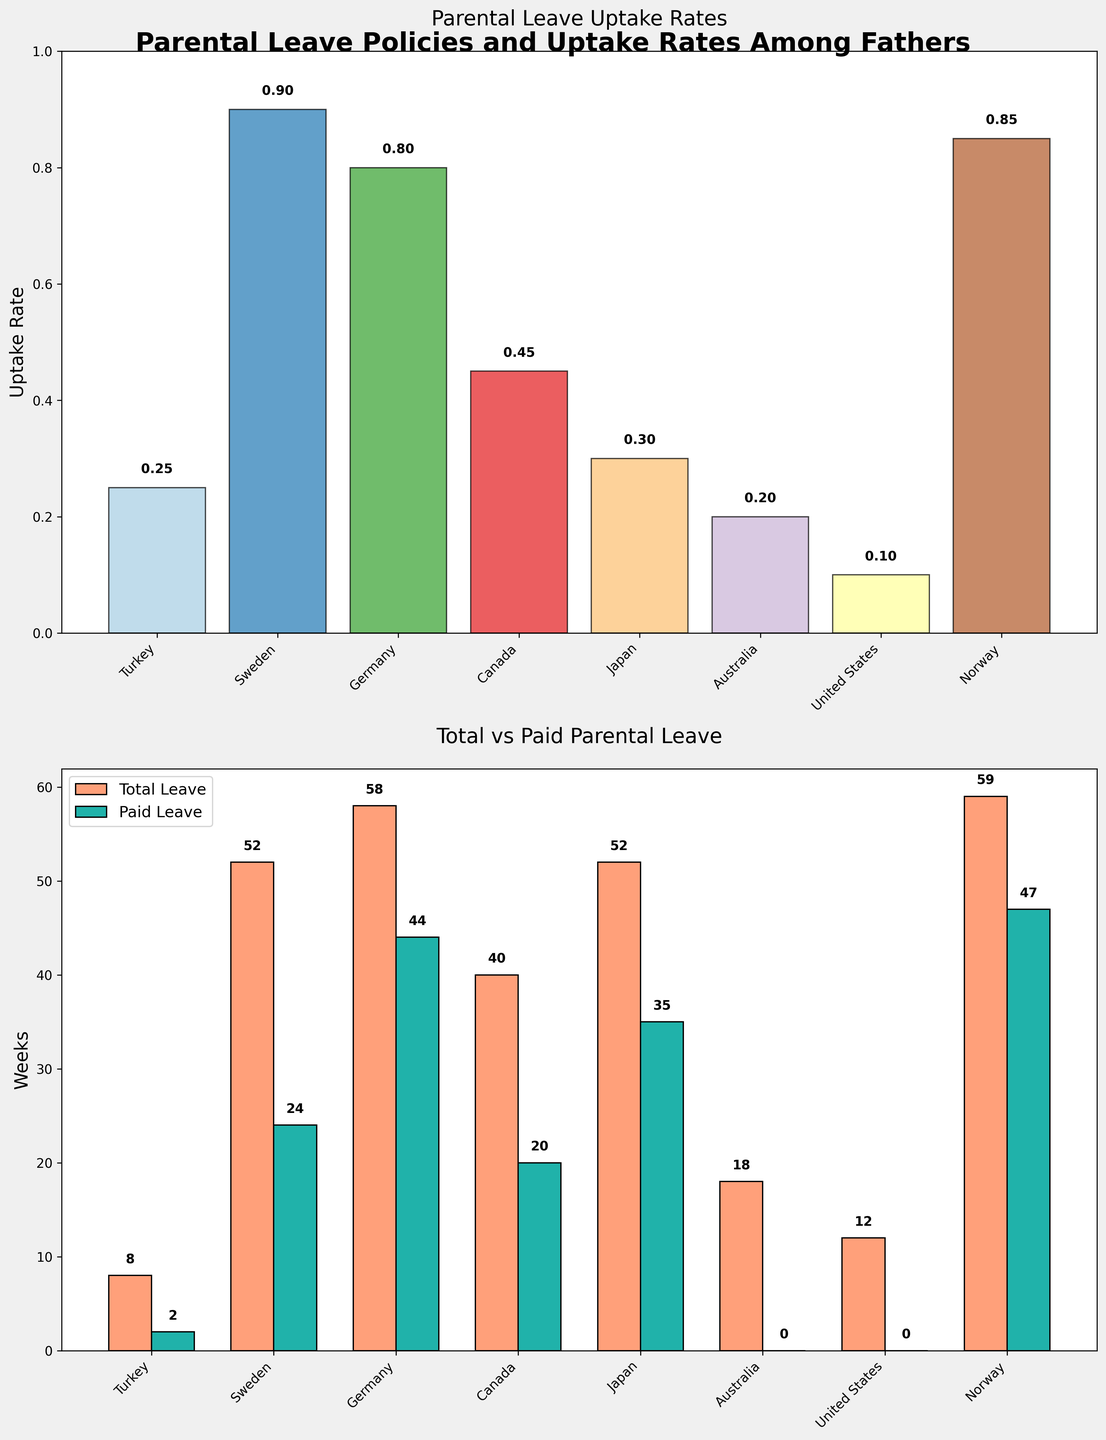What's the uptake rate of parental leave among fathers in Turkey? From the "Parental Leave Uptake Rates" subplot, we see that each country is listed along the x-axis, and Turkey's bar is directly above its label. The uptake rate is indicated by the height of the bars and the number on top. Turkey's bar has an uptake rate of 0.25, which is confirmed by the text label on the bar itself.
Answer: 0.25 Which country has the highest parental leave uptake rate among fathers? In the "Parental Leave Uptake Rates" subplot, the highest bar indicates the highest uptake rate. From visual inspection, Sweden has the tallest bar, and the label above the bar confirms the uptake rate as 0.90, which is the highest among all countries listed.
Answer: Sweden How many weeks of total parental leave does Australia provide compared to Japan? In the "Total vs Paid Parental Leave" subplot, there are two bars for each country, one for total and one for paid leave. Australia's total parental leave is marked above its bar as 18 weeks, and Japan's total leave is marked as 52 weeks. By comparing these, we can see that Japan provides 34 weeks more (52 - 18).
Answer: Japan provides 34 more weeks What percentage of fathers in Norway take parental leave? In the "Parental Leave Uptake Rates" subplot, the uptake rate for Norway can be seen from the height of the bar and the precise number given above it. The value given for Norway is 0.85. This means 85% of fathers take parental leave in Norway.
Answer: 85% In which countries is the paid parental leave the same as the total parental leave? In the "Total vs Paid Parental Leave" subplot, we look for countries where the heights of both bars (total and paid) are equal. From visual inspection, Norway's and Germany's total and paid leave bars are the same height, indicated by 59 weeks and 47 weeks respectively for each country.
Answer: Norway and Germany Compare the total parental leave provided in Sweden and the United States. Which country provides more and by how many weeks? In the "Total vs Paid Parental Leave" subplot, Sweden's total parental leave is labeled as 52 weeks, and the United States' total leave is labeled as 12 weeks. Sweden provides more, and the difference is 52 - 12 = 40 weeks.
Answer: Sweden by 40 weeks What is the total number of weeks of paid parental leave in Canada and Germany combined? In the "Total vs Paid Parental Leave" subplot, Canada's paid leave is labeled as 20 weeks and Germany's is 44 weeks. By summing these values, we get 20 + 44 = 64 weeks.
Answer: 64 weeks Are there any countries with no paid parental leave? If so, which ones? In the "Total vs Paid Parental Leave" subplot, we identify countries with a paid leave bar height of 0. Both Australia's and the United States' paid leave bars are at zero, indicating no paid parental leave.
Answer: Australia and United States What is the average uptake rate of parental leave among fathers in Germany and Japan? From the "Parental Leave Uptake Rates" subplot, Germany's uptake rate is 0.80 and Japan's is 0.30. The average is calculated as (0.80 + 0.30) / 2 = 0.55.
Answer: 0.55 Which country has the smallest difference between total and paid parental leave, and what is that difference? In the "Total vs Paid Parental Leave" subplot, we look for countries where the total and paid leave bars are closest in height. Norway has a total leave of 59 weeks and paid leave of 47 weeks, making the difference 12 weeks (59 - 47). This is the smallest difference among the countries.
Answer: Norway, 12 weeks 